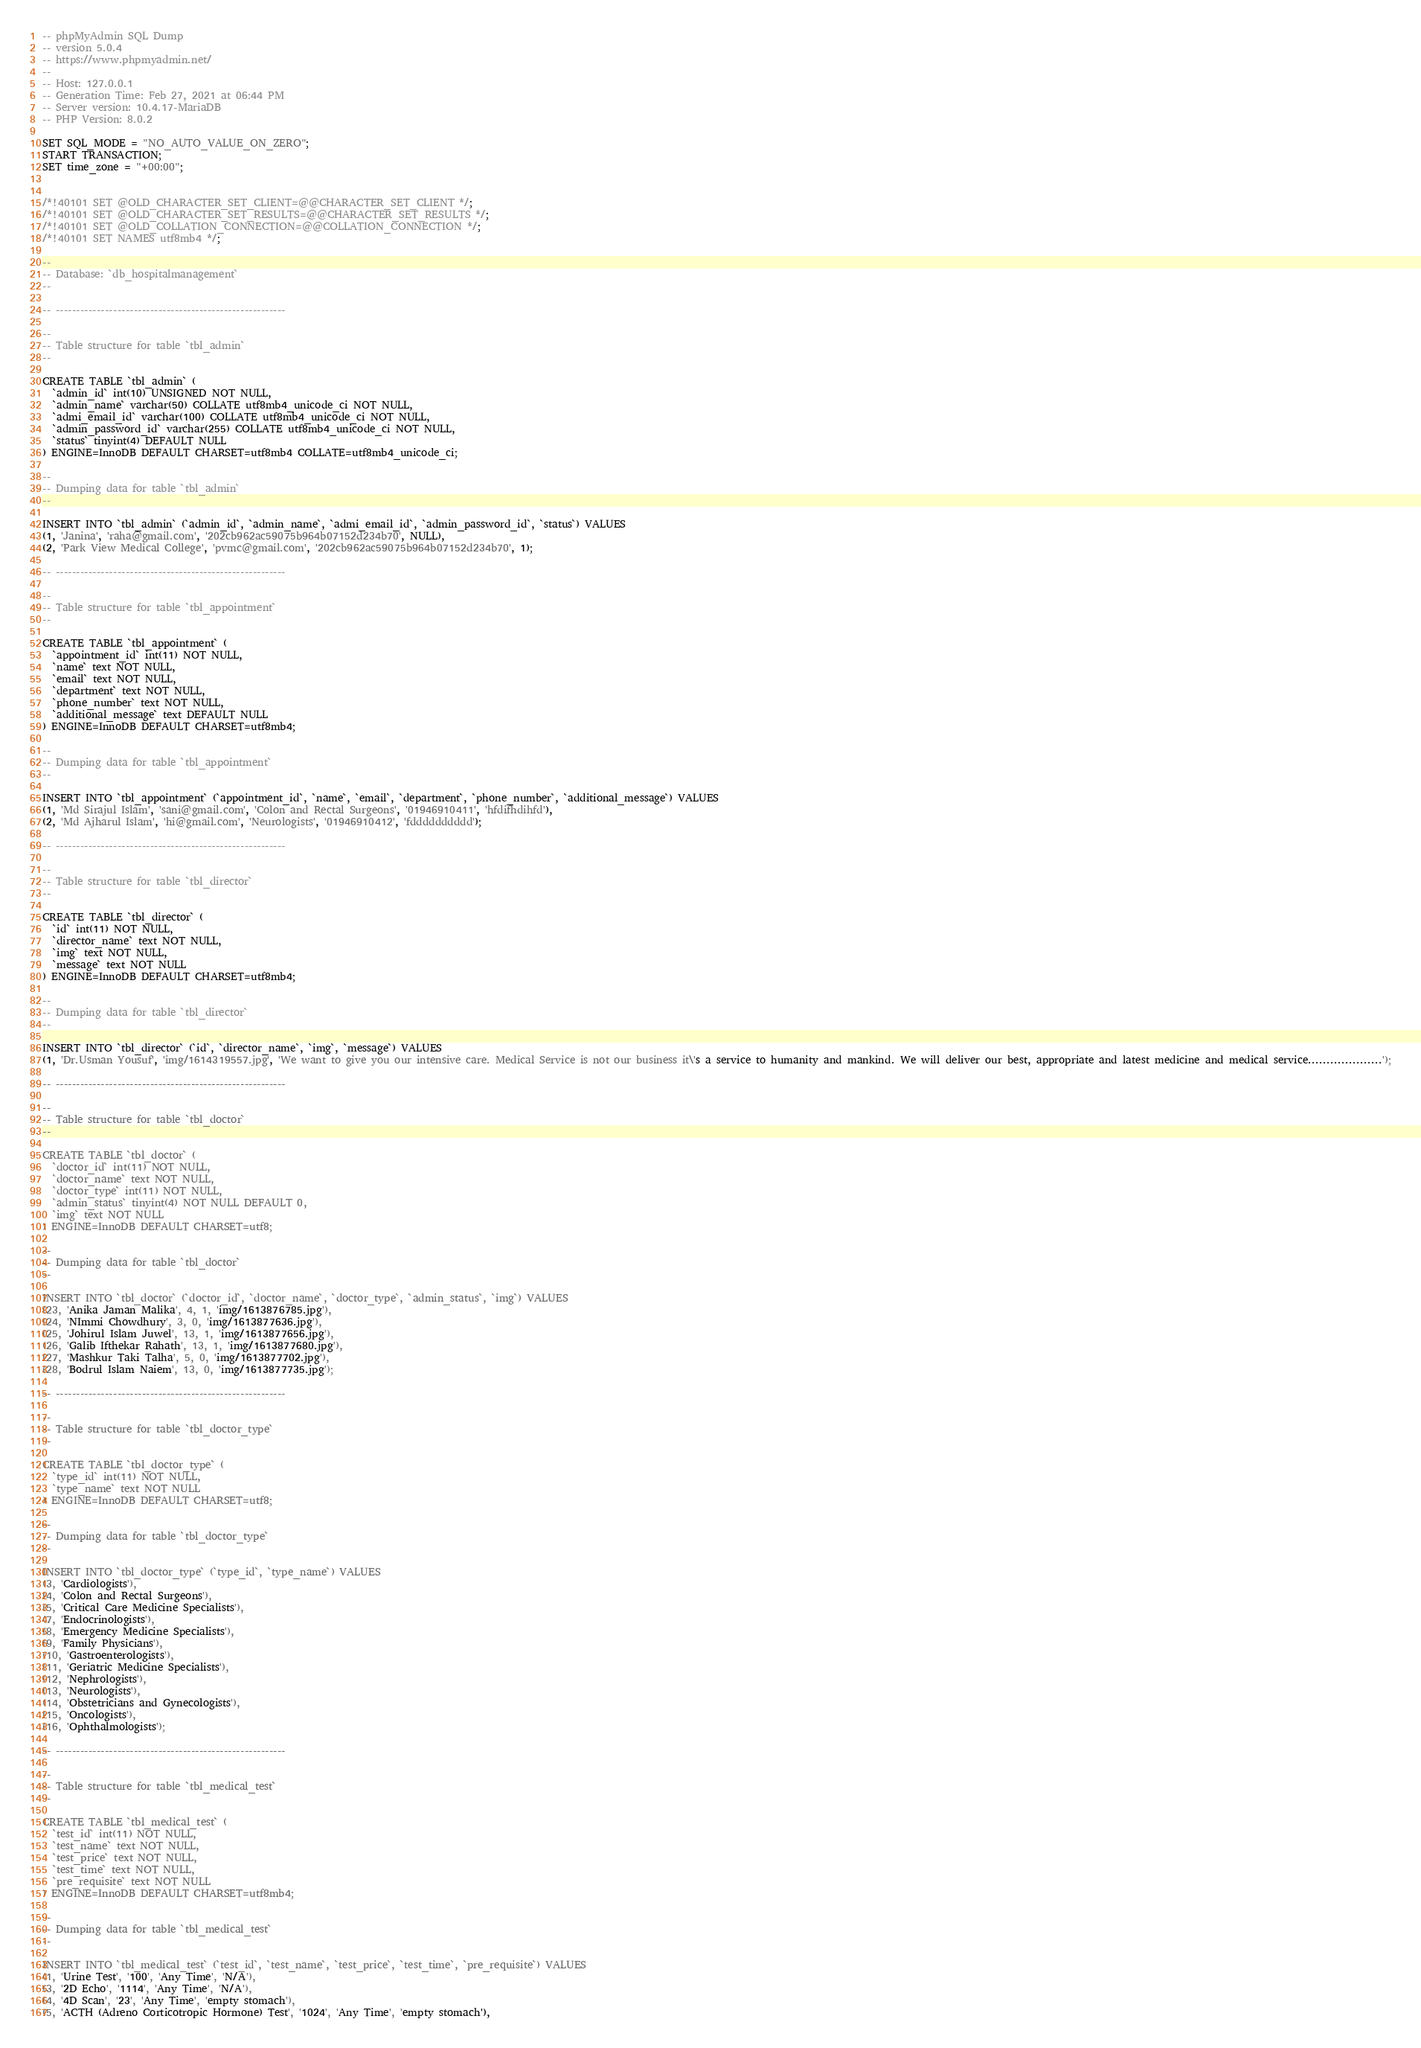<code> <loc_0><loc_0><loc_500><loc_500><_SQL_>-- phpMyAdmin SQL Dump
-- version 5.0.4
-- https://www.phpmyadmin.net/
--
-- Host: 127.0.0.1
-- Generation Time: Feb 27, 2021 at 06:44 PM
-- Server version: 10.4.17-MariaDB
-- PHP Version: 8.0.2

SET SQL_MODE = "NO_AUTO_VALUE_ON_ZERO";
START TRANSACTION;
SET time_zone = "+00:00";


/*!40101 SET @OLD_CHARACTER_SET_CLIENT=@@CHARACTER_SET_CLIENT */;
/*!40101 SET @OLD_CHARACTER_SET_RESULTS=@@CHARACTER_SET_RESULTS */;
/*!40101 SET @OLD_COLLATION_CONNECTION=@@COLLATION_CONNECTION */;
/*!40101 SET NAMES utf8mb4 */;

--
-- Database: `db_hospitalmanagement`
--

-- --------------------------------------------------------

--
-- Table structure for table `tbl_admin`
--

CREATE TABLE `tbl_admin` (
  `admin_id` int(10) UNSIGNED NOT NULL,
  `admin_name` varchar(50) COLLATE utf8mb4_unicode_ci NOT NULL,
  `admi_email_id` varchar(100) COLLATE utf8mb4_unicode_ci NOT NULL,
  `admin_password_id` varchar(255) COLLATE utf8mb4_unicode_ci NOT NULL,
  `status` tinyint(4) DEFAULT NULL
) ENGINE=InnoDB DEFAULT CHARSET=utf8mb4 COLLATE=utf8mb4_unicode_ci;

--
-- Dumping data for table `tbl_admin`
--

INSERT INTO `tbl_admin` (`admin_id`, `admin_name`, `admi_email_id`, `admin_password_id`, `status`) VALUES
(1, 'Janina', 'raha@gmail.com', '202cb962ac59075b964b07152d234b70', NULL),
(2, 'Park View Medical College', 'pvmc@gmail.com', '202cb962ac59075b964b07152d234b70', 1);

-- --------------------------------------------------------

--
-- Table structure for table `tbl_appointment`
--

CREATE TABLE `tbl_appointment` (
  `appointment_id` int(11) NOT NULL,
  `name` text NOT NULL,
  `email` text NOT NULL,
  `department` text NOT NULL,
  `phone_number` text NOT NULL,
  `additional_message` text DEFAULT NULL
) ENGINE=InnoDB DEFAULT CHARSET=utf8mb4;

--
-- Dumping data for table `tbl_appointment`
--

INSERT INTO `tbl_appointment` (`appointment_id`, `name`, `email`, `department`, `phone_number`, `additional_message`) VALUES
(1, 'Md Sirajul Islam', 'sani@gmail.com', 'Colon and Rectal Surgeons', '01946910411', 'hfdifhdihfd'),
(2, 'Md Ajharul Islam', 'hi@gmail.com', 'Neurologists', '01946910412', 'fdddddddddd');

-- --------------------------------------------------------

--
-- Table structure for table `tbl_director`
--

CREATE TABLE `tbl_director` (
  `id` int(11) NOT NULL,
  `director_name` text NOT NULL,
  `img` text NOT NULL,
  `message` text NOT NULL
) ENGINE=InnoDB DEFAULT CHARSET=utf8mb4;

--
-- Dumping data for table `tbl_director`
--

INSERT INTO `tbl_director` (`id`, `director_name`, `img`, `message`) VALUES
(1, 'Dr.Usman Yousuf', 'img/1614319557.jpg', 'We want to give you our intensive care. Medical Service is not our business it\'s a service to humanity and mankind. We will deliver our best, appropriate and latest medicine and medical service....................');

-- --------------------------------------------------------

--
-- Table structure for table `tbl_doctor`
--

CREATE TABLE `tbl_doctor` (
  `doctor_id` int(11) NOT NULL,
  `doctor_name` text NOT NULL,
  `doctor_type` int(11) NOT NULL,
  `admin_status` tinyint(4) NOT NULL DEFAULT 0,
  `img` text NOT NULL
) ENGINE=InnoDB DEFAULT CHARSET=utf8;

--
-- Dumping data for table `tbl_doctor`
--

INSERT INTO `tbl_doctor` (`doctor_id`, `doctor_name`, `doctor_type`, `admin_status`, `img`) VALUES
(23, 'Anika Jaman Malika', 4, 1, 'img/1613876785.jpg'),
(24, 'NImmi Chowdhury', 3, 0, 'img/1613877636.jpg'),
(25, 'Johirul Islam Juwel', 13, 1, 'img/1613877656.jpg'),
(26, 'Galib Ifthekar Rahath', 13, 1, 'img/1613877680.jpg'),
(27, 'Mashkur Taki Talha', 5, 0, 'img/1613877702.jpg'),
(28, 'Bodrul Islam Naiem', 13, 0, 'img/1613877735.jpg');

-- --------------------------------------------------------

--
-- Table structure for table `tbl_doctor_type`
--

CREATE TABLE `tbl_doctor_type` (
  `type_id` int(11) NOT NULL,
  `type_name` text NOT NULL
) ENGINE=InnoDB DEFAULT CHARSET=utf8;

--
-- Dumping data for table `tbl_doctor_type`
--

INSERT INTO `tbl_doctor_type` (`type_id`, `type_name`) VALUES
(3, 'Cardiologists'),
(4, 'Colon and Rectal Surgeons'),
(5, 'Critical Care Medicine Specialists'),
(7, 'Endocrinologists'),
(8, 'Emergency Medicine Specialists'),
(9, 'Family Physicians'),
(10, 'Gastroenterologists'),
(11, 'Geriatric Medicine Specialists'),
(12, 'Nephrologists'),
(13, 'Neurologists'),
(14, 'Obstetricians and Gynecologists'),
(15, 'Oncologists'),
(16, 'Ophthalmologists');

-- --------------------------------------------------------

--
-- Table structure for table `tbl_medical_test`
--

CREATE TABLE `tbl_medical_test` (
  `test_id` int(11) NOT NULL,
  `test_name` text NOT NULL,
  `test_price` text NOT NULL,
  `test_time` text NOT NULL,
  `pre_requisite` text NOT NULL
) ENGINE=InnoDB DEFAULT CHARSET=utf8mb4;

--
-- Dumping data for table `tbl_medical_test`
--

INSERT INTO `tbl_medical_test` (`test_id`, `test_name`, `test_price`, `test_time`, `pre_requisite`) VALUES
(1, 'Urine Test', '100', 'Any Time', 'N/A'),
(3, '2D Echo', '1114', 'Any Time', 'N/A'),
(4, '4D Scan', '23', 'Any Time', 'empty stomach'),
(5, 'ACTH (Adreno Corticotropic Hormone) Test', '1024', 'Any Time', 'empty stomach'),</code> 